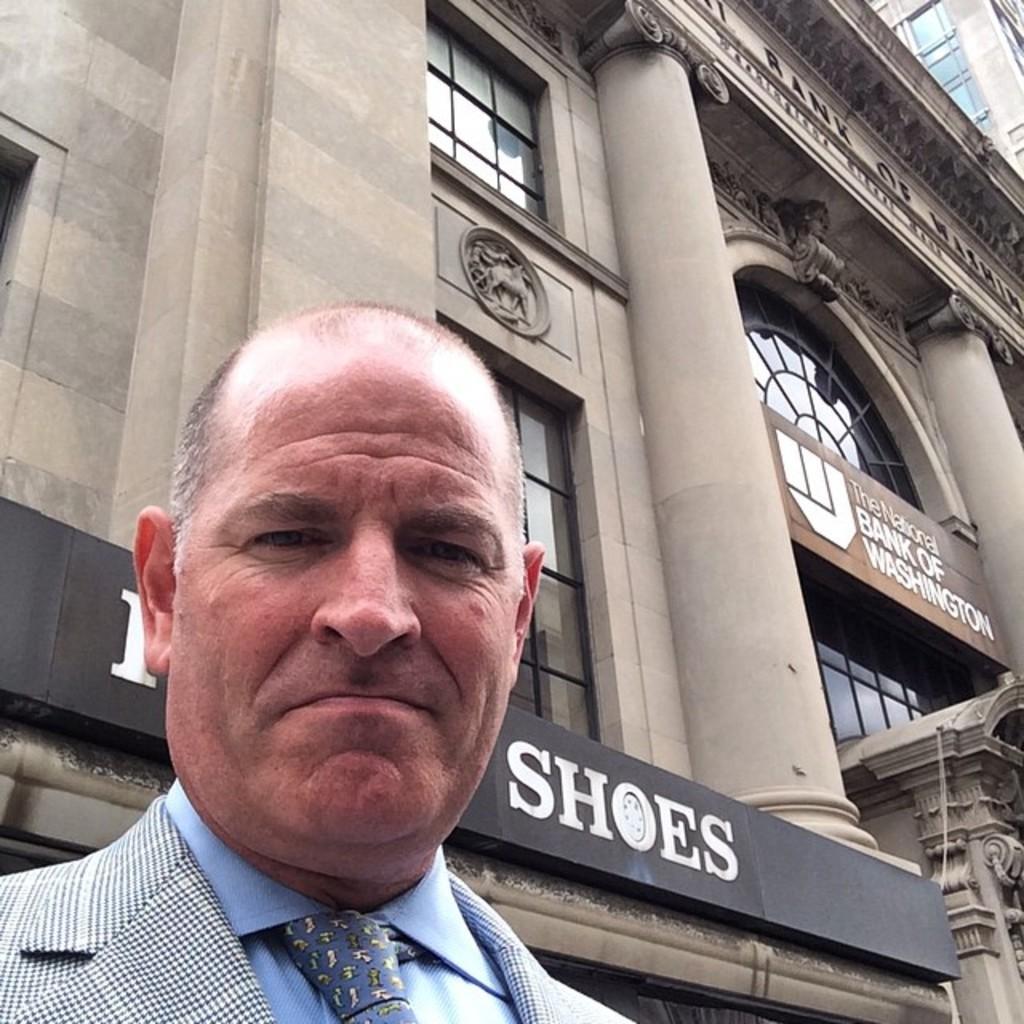How would you summarize this image in a sentence or two? In this image I can see the person standing and wearing the blue color shirt, tie and blazer. In the background I can see the building which is in ash color and I can see the black color board to the building. 